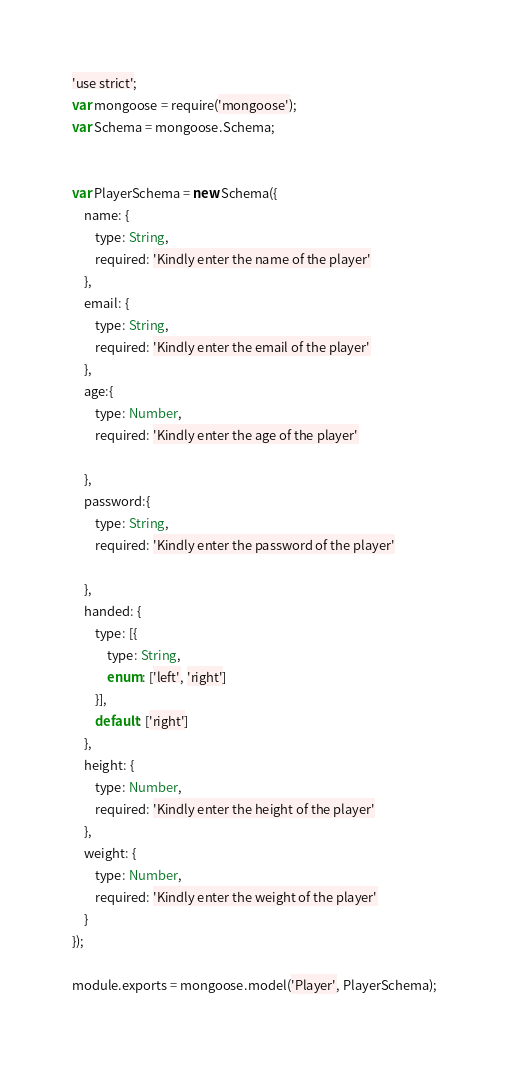<code> <loc_0><loc_0><loc_500><loc_500><_JavaScript_>'use strict';
var mongoose = require('mongoose');
var Schema = mongoose.Schema;


var PlayerSchema = new Schema({
    name: {
        type: String,
        required: 'Kindly enter the name of the player'
    },
    email: {
        type: String,
        required: 'Kindly enter the email of the player'
    },
    age:{
        type: Number,
        required: 'Kindly enter the age of the player'

    },
    password:{
        type: String,
        required: 'Kindly enter the password of the player'

    },
    handed: {
        type: [{
            type: String,
            enum: ['left', 'right']
        }],
        default: ['right']
    },
    height: {
        type: Number,
        required: 'Kindly enter the height of the player'
    },
    weight: {
        type: Number,
        required: 'Kindly enter the weight of the player'
    }
});

module.exports = mongoose.model('Player', PlayerSchema);
</code> 